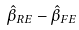Convert formula to latex. <formula><loc_0><loc_0><loc_500><loc_500>\hat { \beta } _ { R E } - \hat { \beta } _ { F E }</formula> 